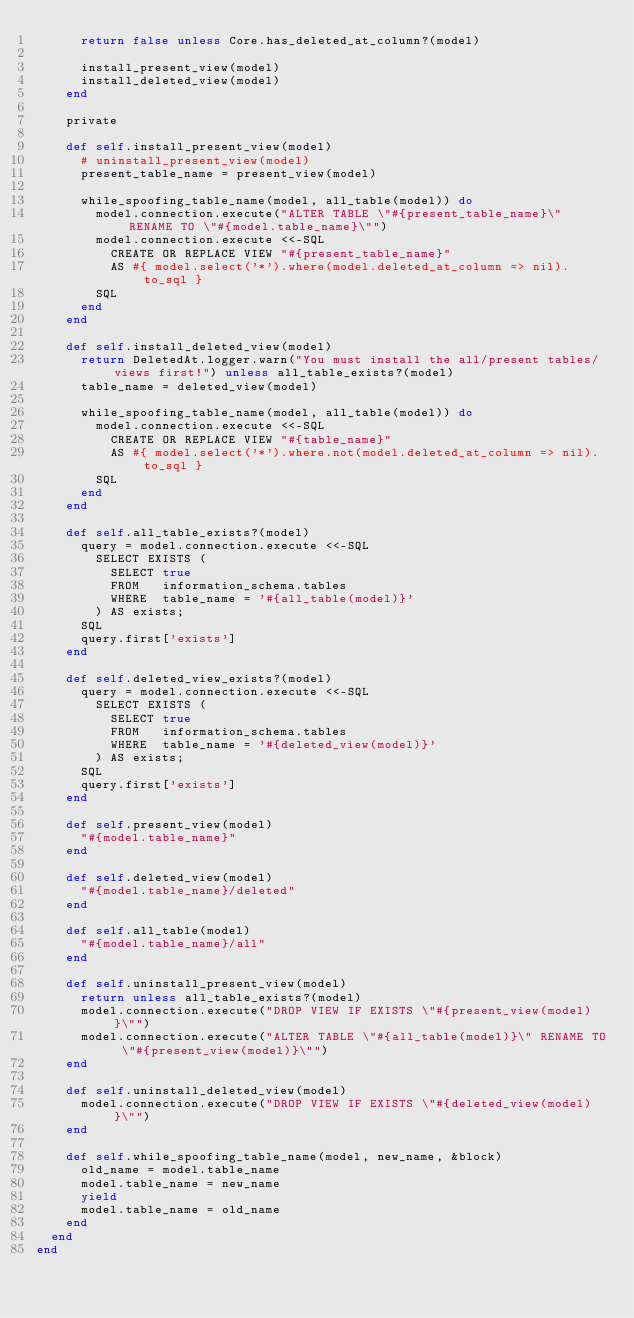<code> <loc_0><loc_0><loc_500><loc_500><_Ruby_>      return false unless Core.has_deleted_at_column?(model)

      install_present_view(model)
      install_deleted_view(model)
    end

    private

    def self.install_present_view(model)
      # uninstall_present_view(model)
      present_table_name = present_view(model)

      while_spoofing_table_name(model, all_table(model)) do
        model.connection.execute("ALTER TABLE \"#{present_table_name}\" RENAME TO \"#{model.table_name}\"")
        model.connection.execute <<-SQL
          CREATE OR REPLACE VIEW "#{present_table_name}"
          AS #{ model.select('*').where(model.deleted_at_column => nil).to_sql }
        SQL
      end
    end

    def self.install_deleted_view(model)
      return DeletedAt.logger.warn("You must install the all/present tables/views first!") unless all_table_exists?(model)
      table_name = deleted_view(model)

      while_spoofing_table_name(model, all_table(model)) do
        model.connection.execute <<-SQL
          CREATE OR REPLACE VIEW "#{table_name}"
          AS #{ model.select('*').where.not(model.deleted_at_column => nil).to_sql }
        SQL
      end
    end

    def self.all_table_exists?(model)
      query = model.connection.execute <<-SQL
        SELECT EXISTS (
          SELECT true
          FROM   information_schema.tables
          WHERE  table_name = '#{all_table(model)}'
        ) AS exists;
      SQL
      query.first['exists']
    end

    def self.deleted_view_exists?(model)
      query = model.connection.execute <<-SQL
        SELECT EXISTS (
          SELECT true
          FROM   information_schema.tables
          WHERE  table_name = '#{deleted_view(model)}'
        ) AS exists;
      SQL
      query.first['exists']
    end

    def self.present_view(model)
      "#{model.table_name}"
    end

    def self.deleted_view(model)
      "#{model.table_name}/deleted"
    end

    def self.all_table(model)
      "#{model.table_name}/all"
    end

    def self.uninstall_present_view(model)
      return unless all_table_exists?(model)
      model.connection.execute("DROP VIEW IF EXISTS \"#{present_view(model)}\"")
      model.connection.execute("ALTER TABLE \"#{all_table(model)}\" RENAME TO \"#{present_view(model)}\"")
    end

    def self.uninstall_deleted_view(model)
      model.connection.execute("DROP VIEW IF EXISTS \"#{deleted_view(model)}\"")
    end

    def self.while_spoofing_table_name(model, new_name, &block)
      old_name = model.table_name
      model.table_name = new_name
      yield
      model.table_name = old_name
    end
  end
end
</code> 